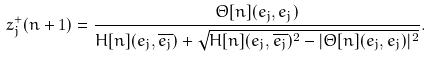Convert formula to latex. <formula><loc_0><loc_0><loc_500><loc_500>z _ { j } ^ { + } ( n + 1 ) = \frac { \Theta [ n ] ( e _ { j } , e _ { j } ) } { H [ n ] ( e _ { j } , \overline { e _ { j } } ) + \sqrt { H [ n ] ( e _ { j } , \overline { e _ { j } } ) ^ { 2 } - | \Theta [ n ] ( e _ { j } , e _ { j } ) | ^ { 2 } } } .</formula> 